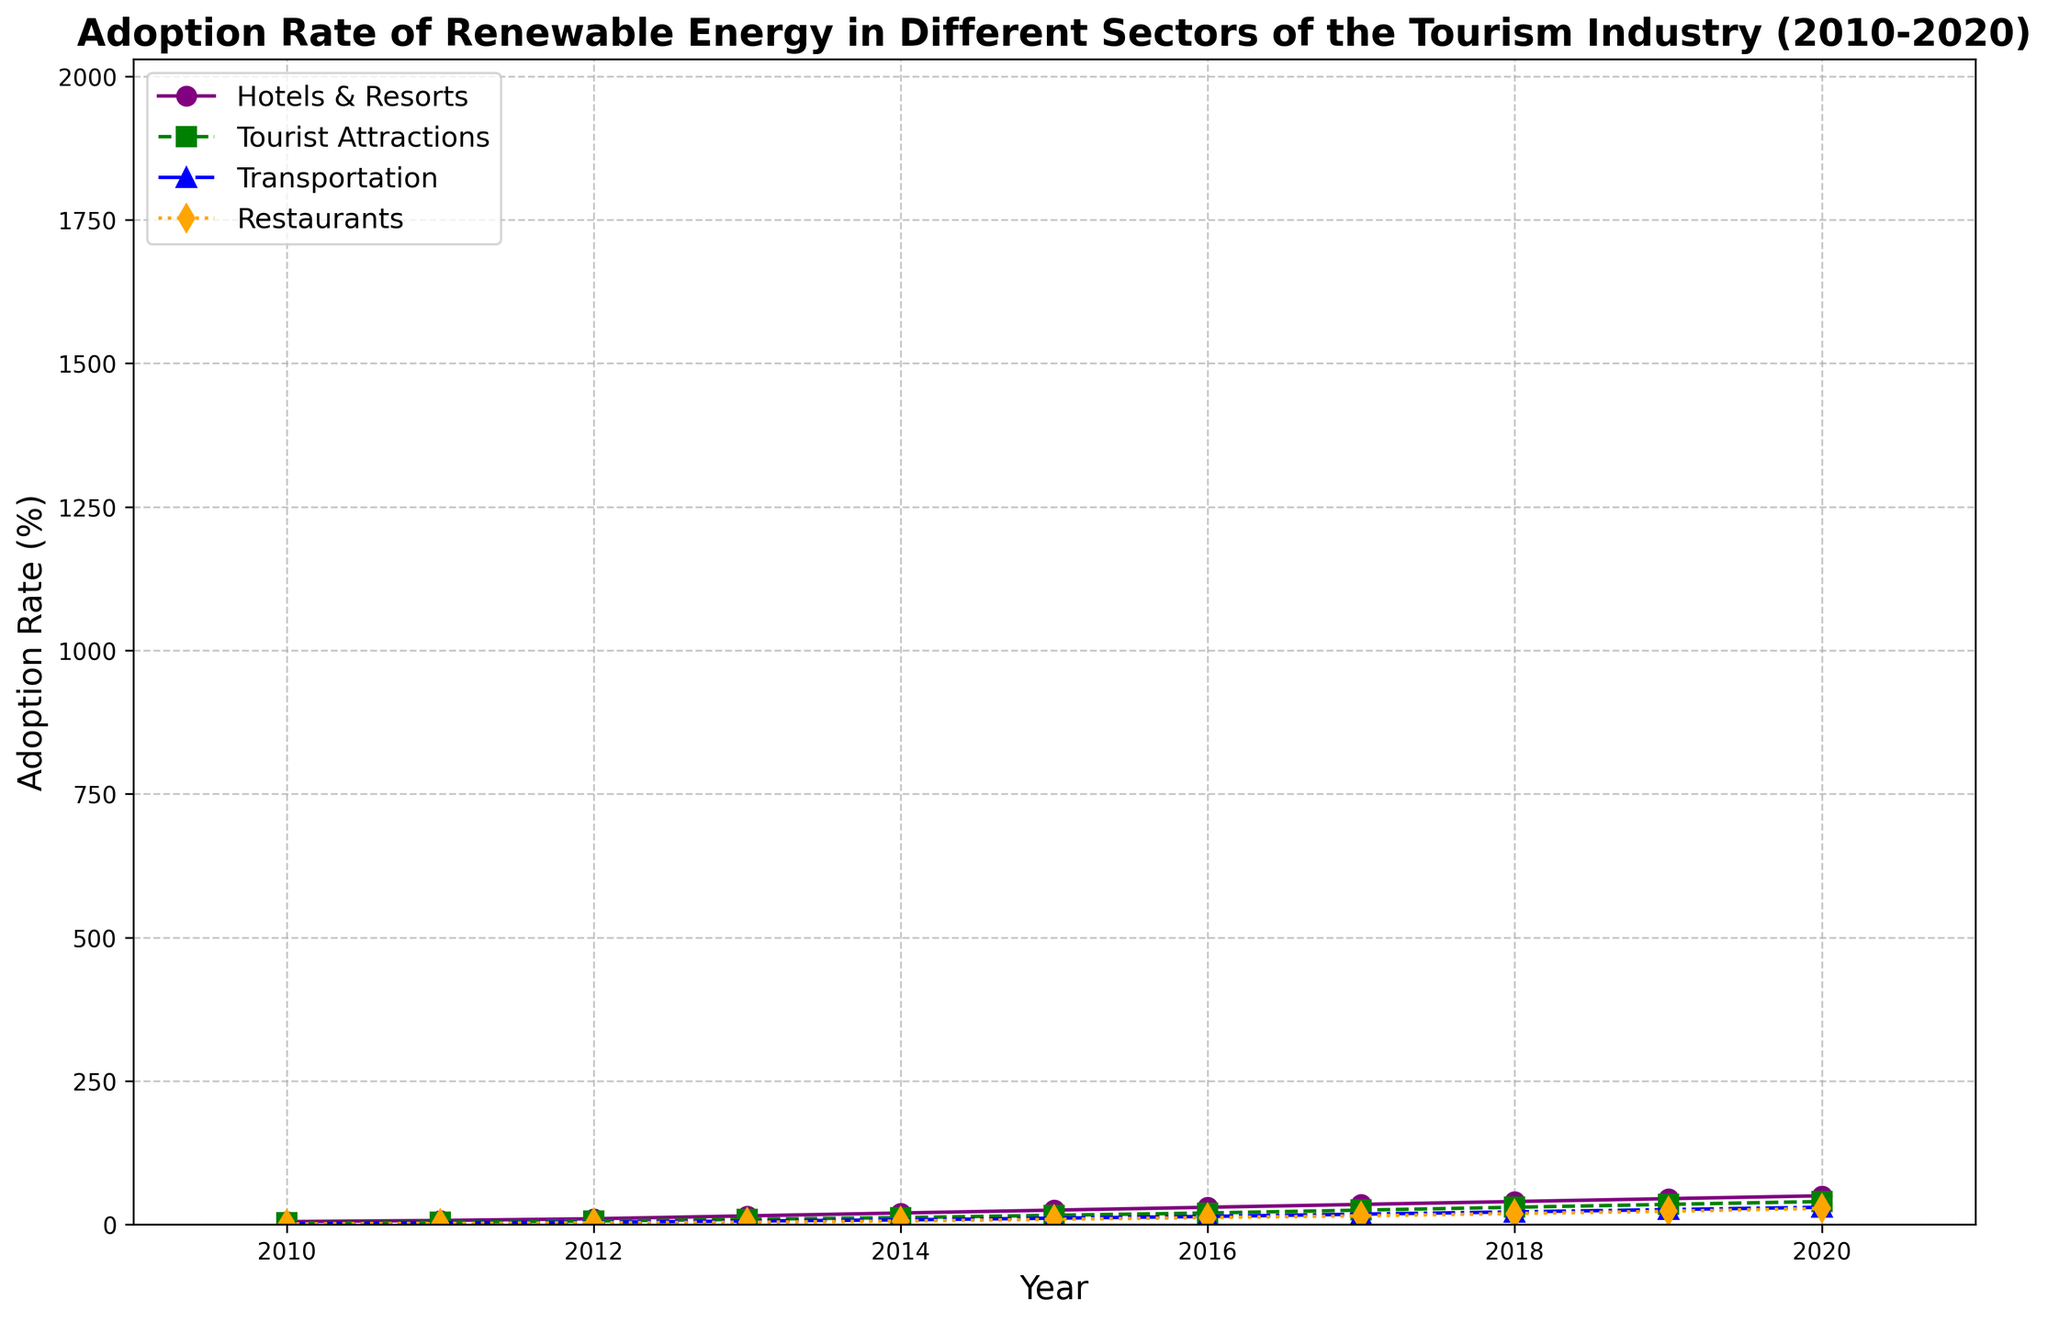What is the adoption rate of renewable energy in Restaurants in 2013? Look at the line representing Restaurants and find its value at the year 2013.
Answer: 4% What was the increase in adoption rate of renewable energy in Hotels & Resorts from 2012 to 2016? Identify the values for Hotels & Resorts in 2012 and 2016, then subtract the 2012 value from the 2016 value. (30 - 10 = 20)
Answer: 20% Which sector saw the greatest increase in renewable energy adoption from 2010 to 2020? Observe the end values of all sectors in 2020 and then compare these with their initial values in 2010. Hotels & Resorts increased from 5% to 50% which is a 45% increase, the largest.
Answer: Hotels & Resorts In what year did Tourist Attractions surpass a 20% adoption rate for renewable energy? Find the first year where the Tourist Attractions line crosses above the 20% mark.
Answer: 2016 How does the adoption rate in Transportation in 2019 compare to Restaurants in the same year? Identify the values for Transportation and Restaurants in 2019 and compare. Transportation is at 26% and Restaurants at 23%.
Answer: Transportation had a 3% higher adoption rate What was the average adoption rate of renewable energy in Tourist Attractions from 2010 to 2020? Sum the yearly adoption rates for Tourist Attractions from 2010 to 2020 and divide by the number of years (3 + 4 + 6 + 9 + 12 + 16 + 20 + 25 + 30 + 35 + 40) / 11 = 20
Answer: 20% In which year did the adoption rate of renewable energy in Transportation reach 10%? Locate 10% on the Transportation line and check the corresponding year.
Answer: 2015 Between Restaurants and Tourist Attractions, which sector had a higher adoption rate of renewable energy in 2014? Compare the adoption rates in 2014 for Restaurants (6%) and Tourist Attractions (12%).
Answer: Tourist Attractions What is the difference in adoption rate between Hotels & Resorts and Transportation in 2020? Identify the adoption rates for Hotels & Resorts (50%) and Transportation (30%) in 2020 and subtract the Transportation value from Hotels & Resorts. (50 - 30 = 20)
Answer: 20% Identify the color used for the line representing Tourist Attractions. Observe the color associated with the label 'Tourist Attractions' and the corresponding line in the chart.
Answer: Green 